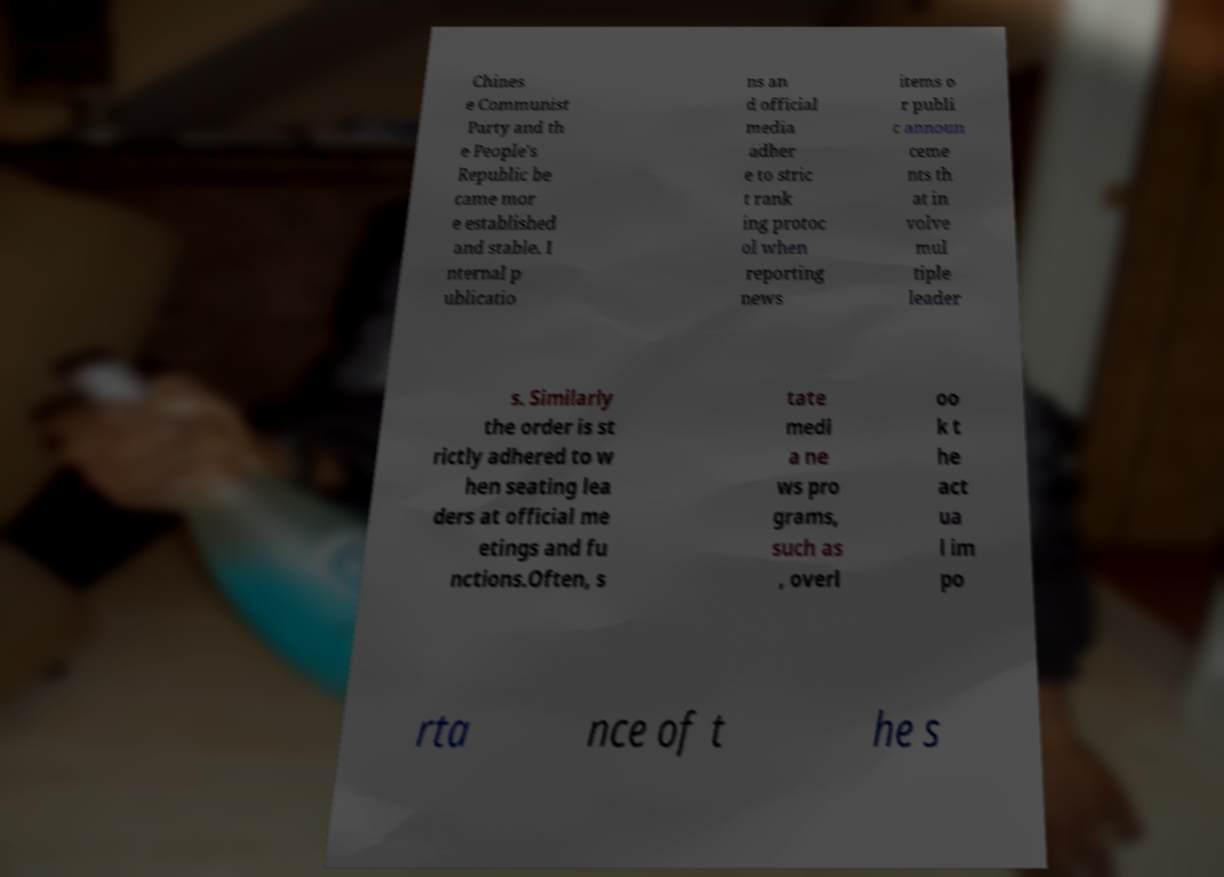Please read and relay the text visible in this image. What does it say? Chines e Communist Party and th e People's Republic be came mor e established and stable. I nternal p ublicatio ns an d official media adher e to stric t rank ing protoc ol when reporting news items o r publi c announ ceme nts th at in volve mul tiple leader s. Similarly the order is st rictly adhered to w hen seating lea ders at official me etings and fu nctions.Often, s tate medi a ne ws pro grams, such as , overl oo k t he act ua l im po rta nce of t he s 